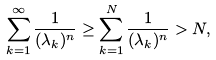<formula> <loc_0><loc_0><loc_500><loc_500>\sum _ { k = 1 } ^ { \infty } \frac { 1 } { ( \lambda _ { k } ) ^ { n } } \geq \sum _ { k = 1 } ^ { N } \frac { 1 } { ( \lambda _ { k } ) ^ { n } } > N ,</formula> 